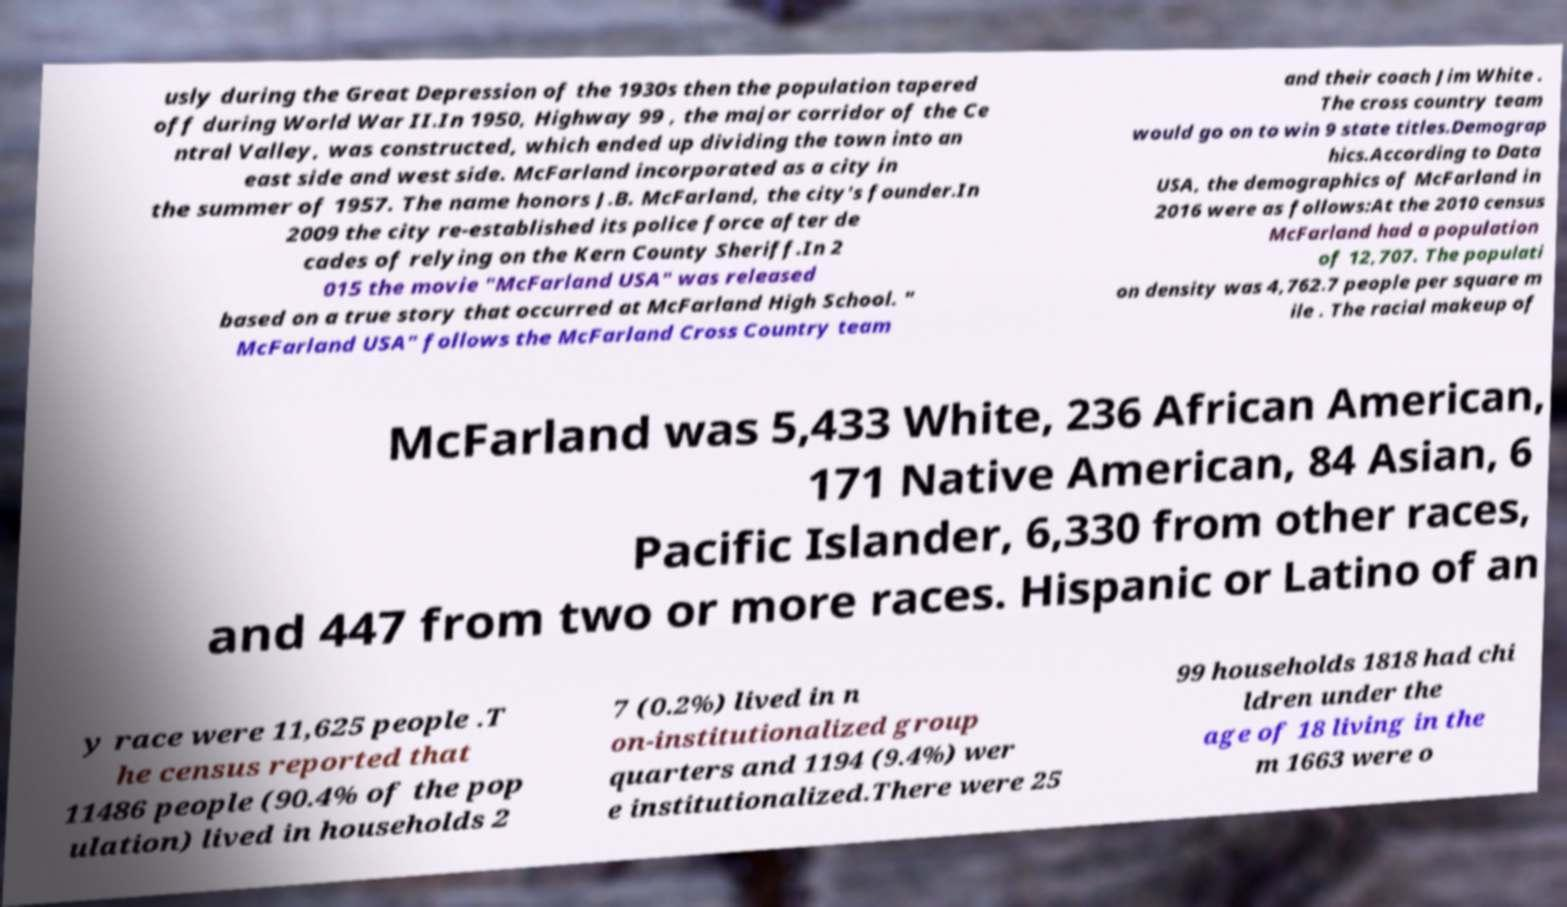What messages or text are displayed in this image? I need them in a readable, typed format. usly during the Great Depression of the 1930s then the population tapered off during World War II.In 1950, Highway 99 , the major corridor of the Ce ntral Valley, was constructed, which ended up dividing the town into an east side and west side. McFarland incorporated as a city in the summer of 1957. The name honors J.B. McFarland, the city's founder.In 2009 the city re-established its police force after de cades of relying on the Kern County Sheriff.In 2 015 the movie "McFarland USA" was released based on a true story that occurred at McFarland High School. " McFarland USA" follows the McFarland Cross Country team and their coach Jim White . The cross country team would go on to win 9 state titles.Demograp hics.According to Data USA, the demographics of McFarland in 2016 were as follows:At the 2010 census McFarland had a population of 12,707. The populati on density was 4,762.7 people per square m ile . The racial makeup of McFarland was 5,433 White, 236 African American, 171 Native American, 84 Asian, 6 Pacific Islander, 6,330 from other races, and 447 from two or more races. Hispanic or Latino of an y race were 11,625 people .T he census reported that 11486 people (90.4% of the pop ulation) lived in households 2 7 (0.2%) lived in n on-institutionalized group quarters and 1194 (9.4%) wer e institutionalized.There were 25 99 households 1818 had chi ldren under the age of 18 living in the m 1663 were o 